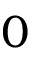Convert formula to latex. <formula><loc_0><loc_0><loc_500><loc_500>0</formula> 